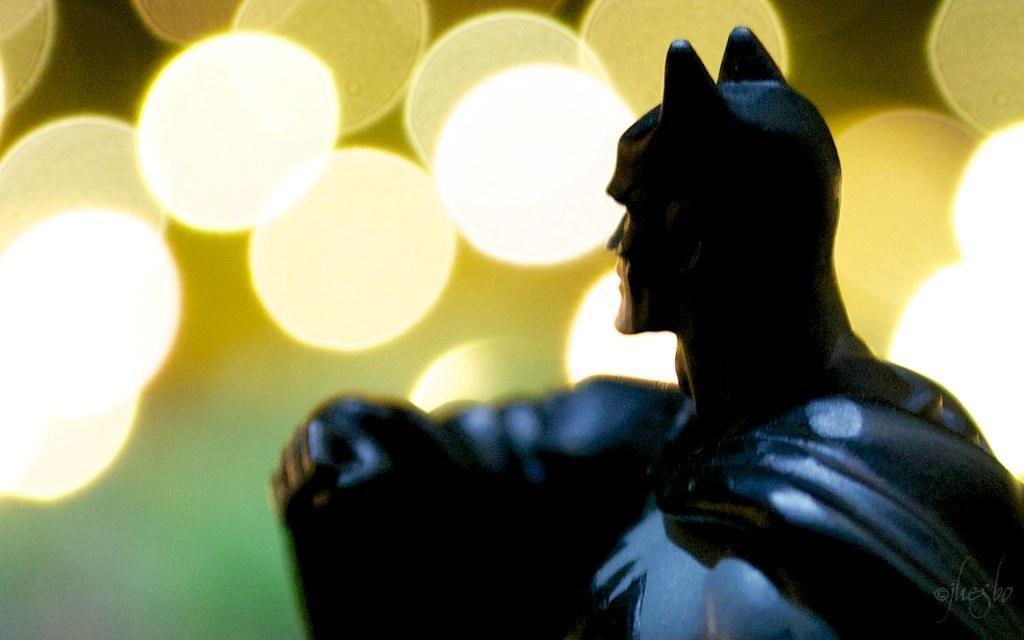Can you describe this image briefly? On the right side it is a doll in the shape of batman in black color, on the left side there are lights. 